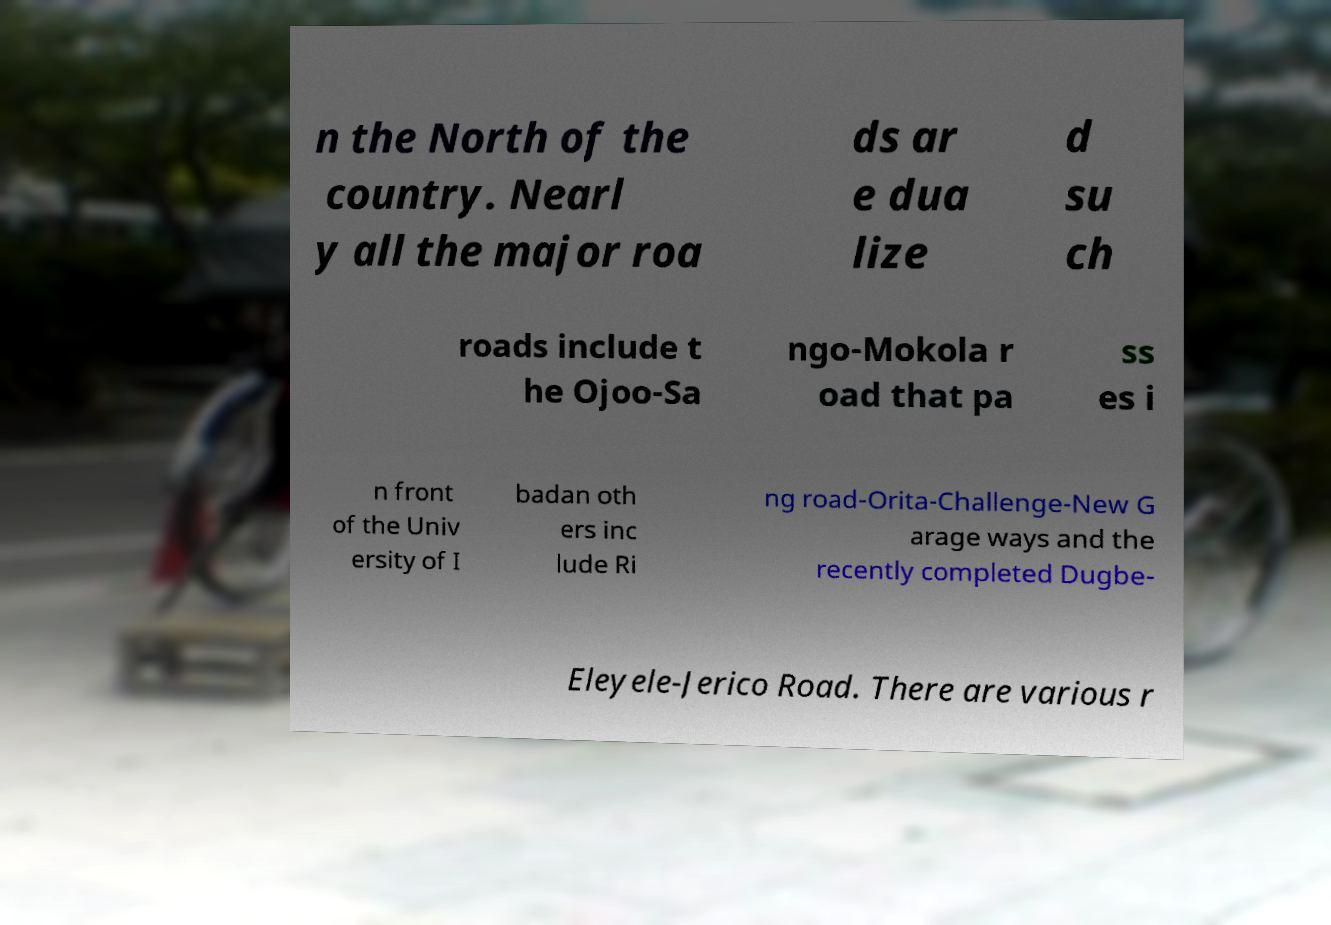Could you extract and type out the text from this image? n the North of the country. Nearl y all the major roa ds ar e dua lize d su ch roads include t he Ojoo-Sa ngo-Mokola r oad that pa ss es i n front of the Univ ersity of I badan oth ers inc lude Ri ng road-Orita-Challenge-New G arage ways and the recently completed Dugbe- Eleyele-Jerico Road. There are various r 